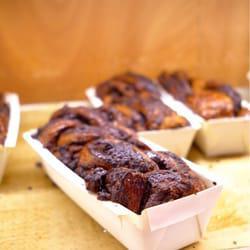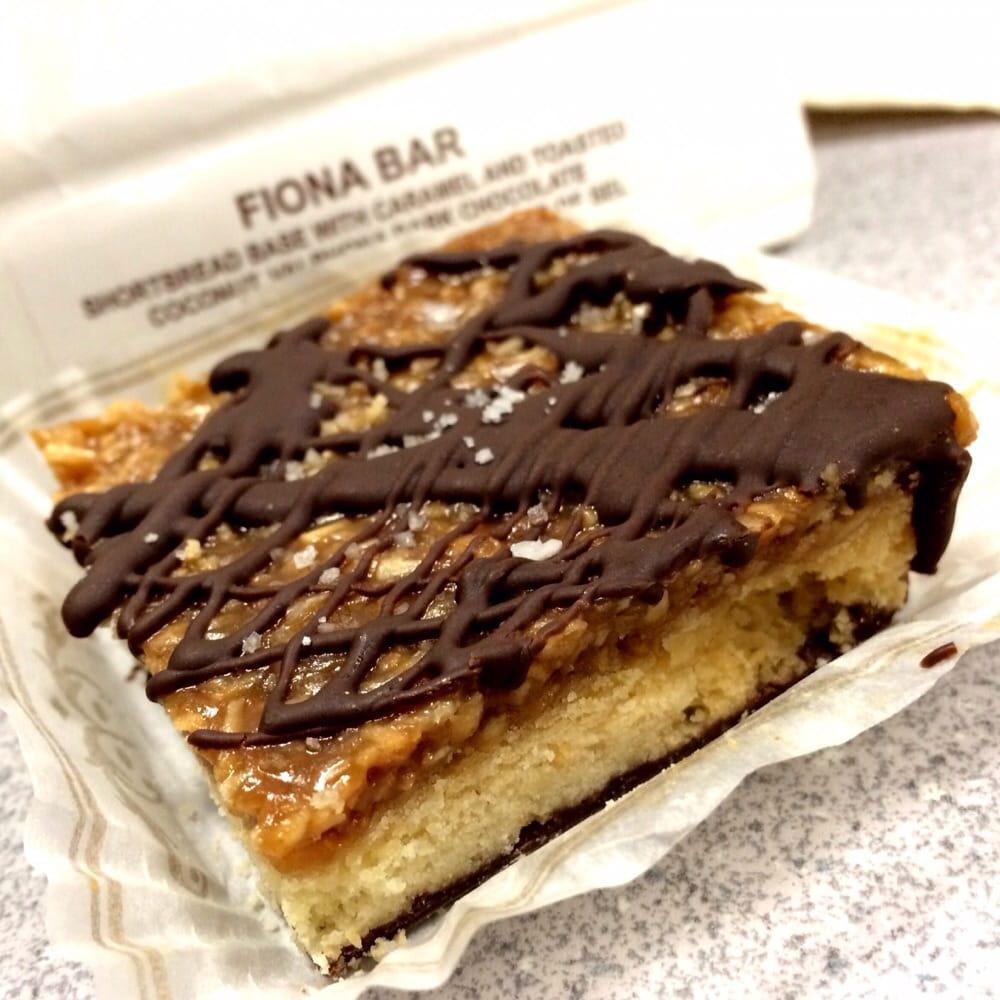The first image is the image on the left, the second image is the image on the right. Given the left and right images, does the statement "Loaves of bakery items are sitting in white rectangular containers in the image on the left." hold true? Answer yes or no. Yes. 